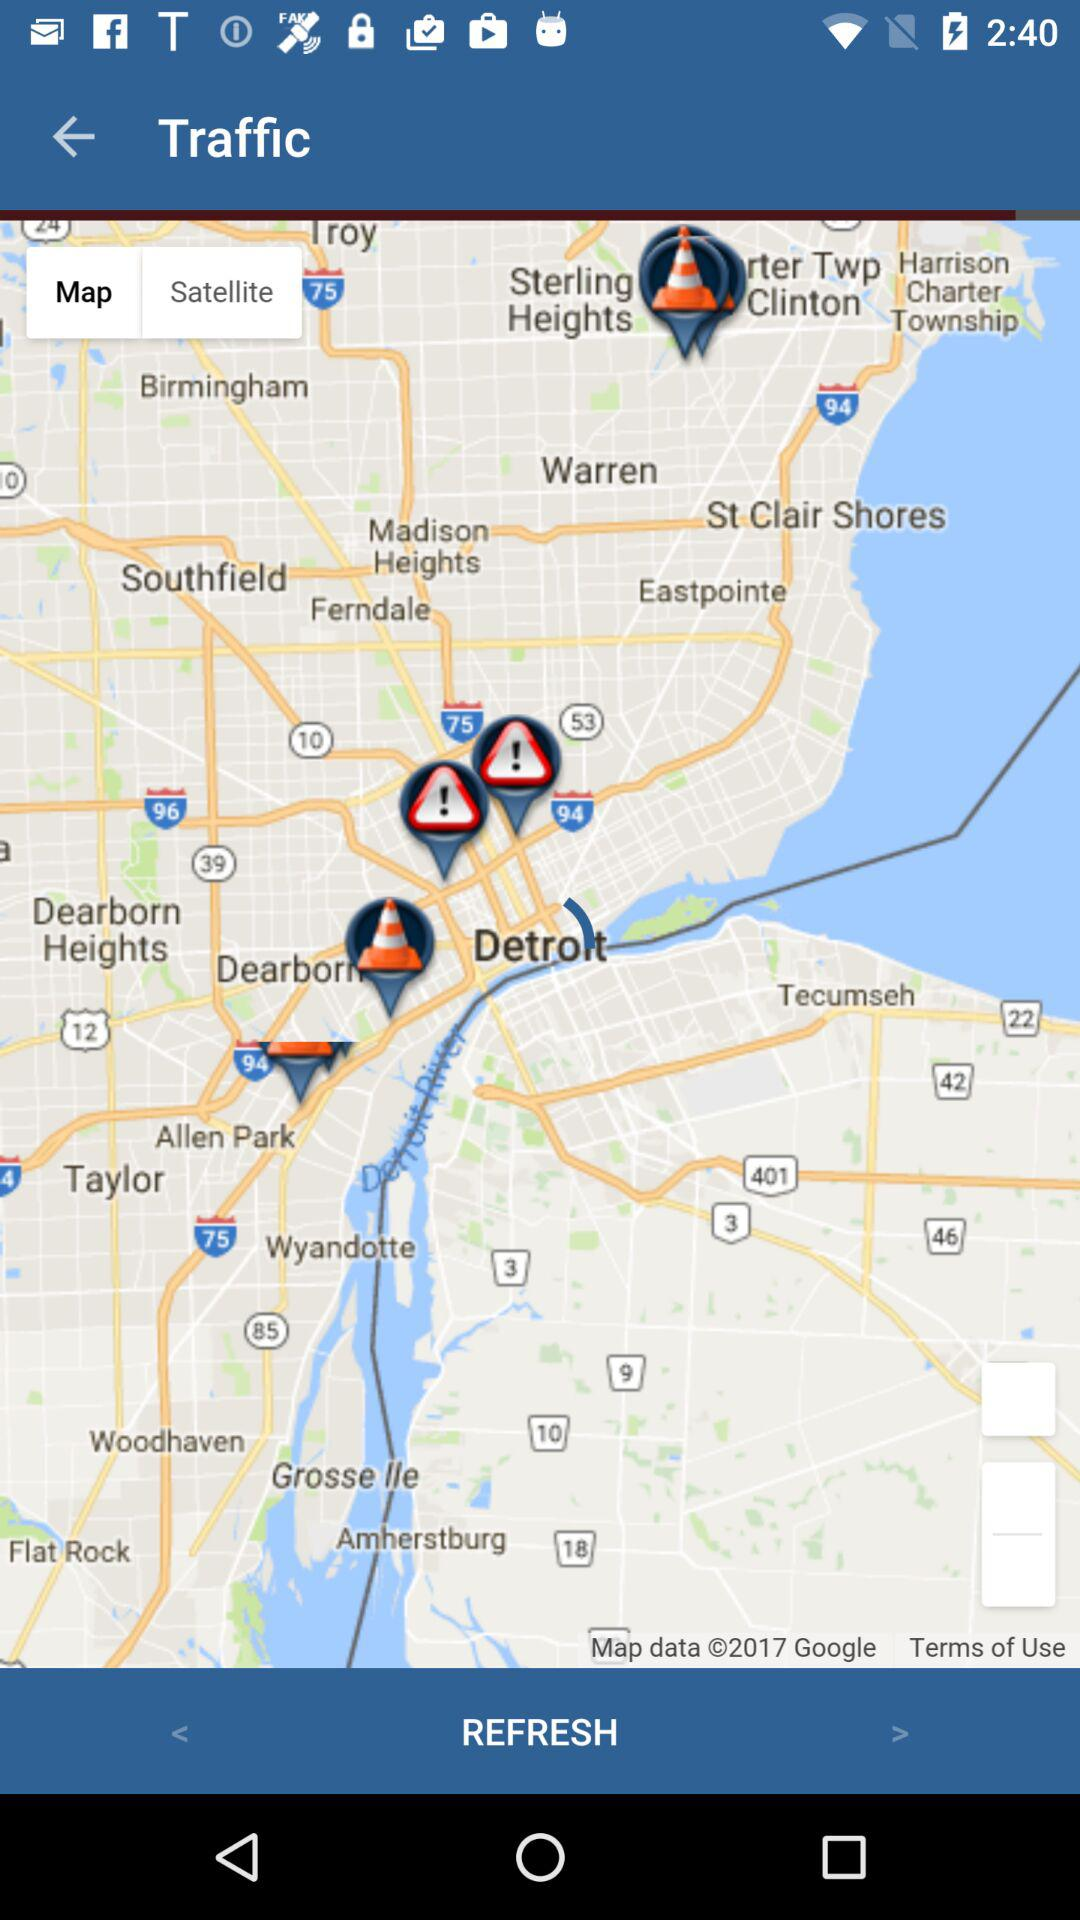How many squares are in the map?
Answer the question using a single word or phrase. 2 